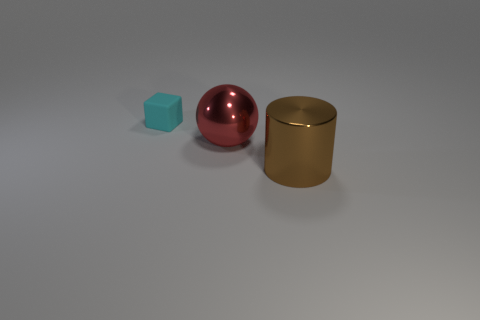Subtract all spheres. How many objects are left? 2 Add 1 brown cylinders. How many objects exist? 4 Add 1 big brown metallic cylinders. How many big brown metallic cylinders exist? 2 Subtract 0 purple cylinders. How many objects are left? 3 Subtract all cyan matte cubes. Subtract all brown things. How many objects are left? 1 Add 2 big red things. How many big red things are left? 3 